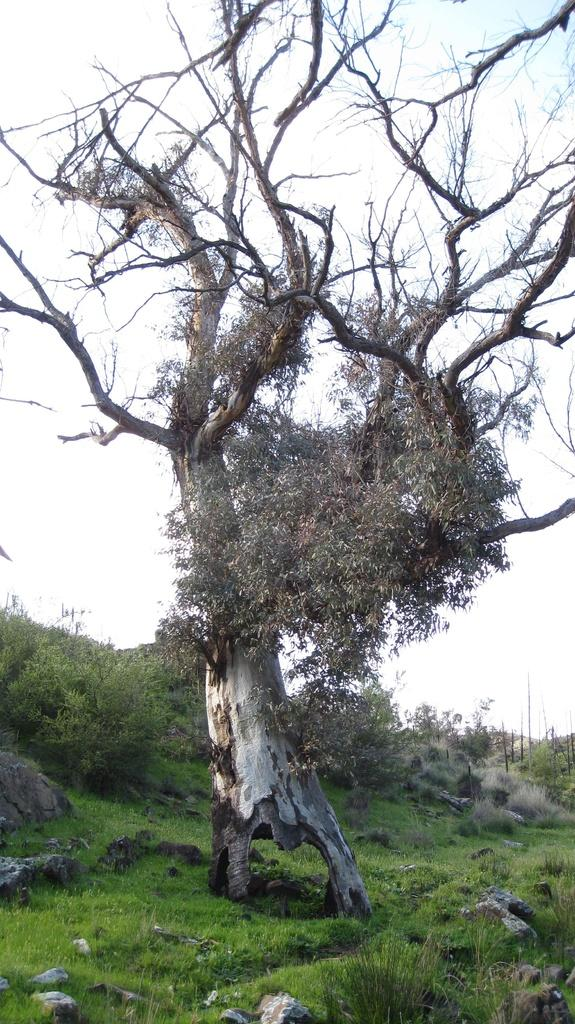What is the main subject in the center of the image? There is a tree in the center of the image. What type of vegetation is in the foreground? There is grass in the foreground. What else can be seen in the foreground besides grass? There are rocks in the foreground. What can be seen in the background of the image? There are plants visible in the background, and the sky is also visible. What type of thunder can be heard in the image? There is no sound present in the image, so it is not possible to determine if thunder can be heard. 